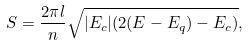<formula> <loc_0><loc_0><loc_500><loc_500>S = \frac { 2 \pi l } { n } \sqrt { | E _ { c } | ( 2 ( E - E _ { q } ) - E _ { c } ) } ,</formula> 